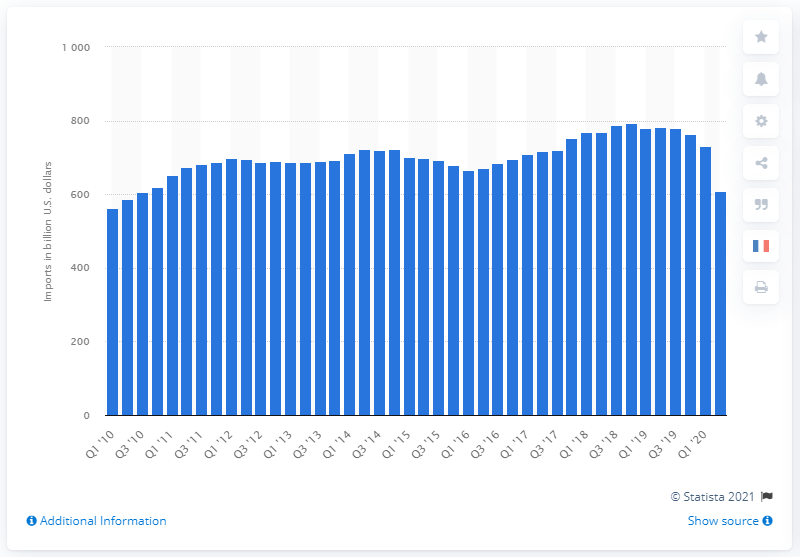Identify some key points in this picture. In the second quarter of 2020, the United States imported a total of 609.55 dollars' worth of goods and services. 